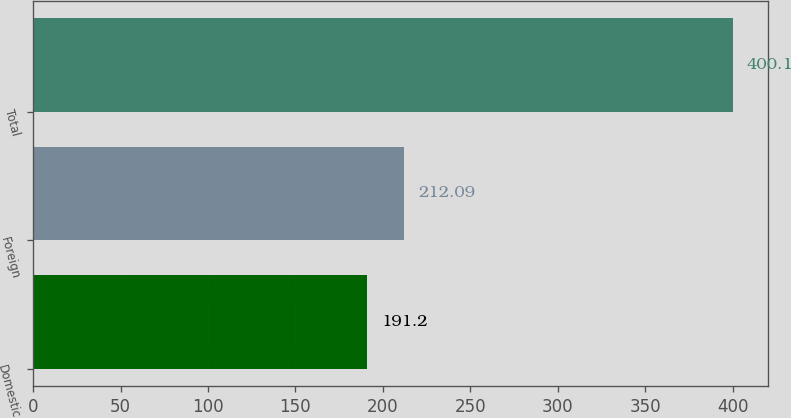Convert chart to OTSL. <chart><loc_0><loc_0><loc_500><loc_500><bar_chart><fcel>Domestic<fcel>Foreign<fcel>Total<nl><fcel>191.2<fcel>212.09<fcel>400.1<nl></chart> 